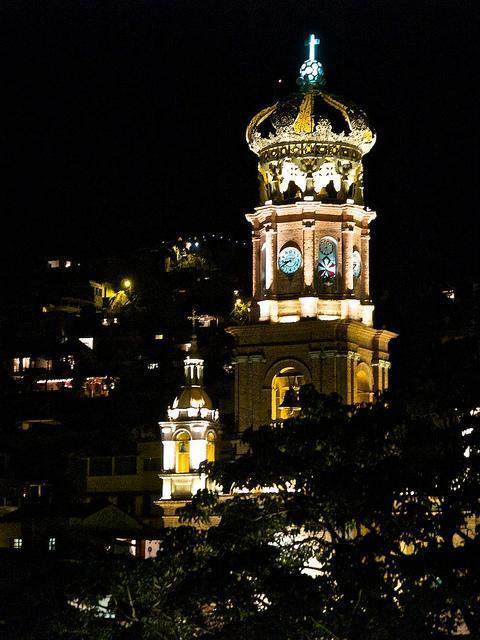How many people are in the plane?
Give a very brief answer. 0. 